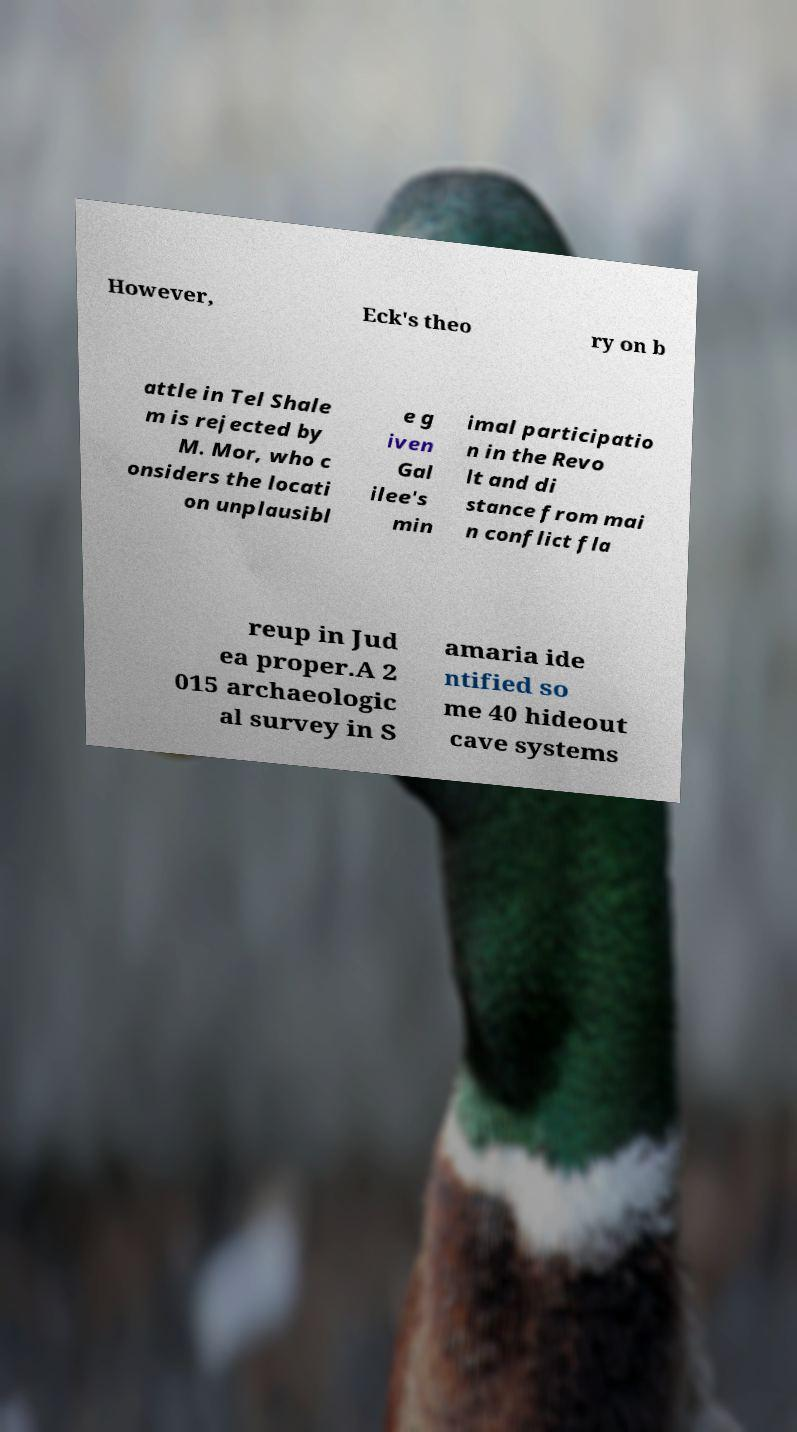What messages or text are displayed in this image? I need them in a readable, typed format. However, Eck's theo ry on b attle in Tel Shale m is rejected by M. Mor, who c onsiders the locati on unplausibl e g iven Gal ilee's min imal participatio n in the Revo lt and di stance from mai n conflict fla reup in Jud ea proper.A 2 015 archaeologic al survey in S amaria ide ntified so me 40 hideout cave systems 